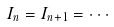Convert formula to latex. <formula><loc_0><loc_0><loc_500><loc_500>I _ { n } = I _ { n + 1 } = \cdot \cdot \cdot</formula> 